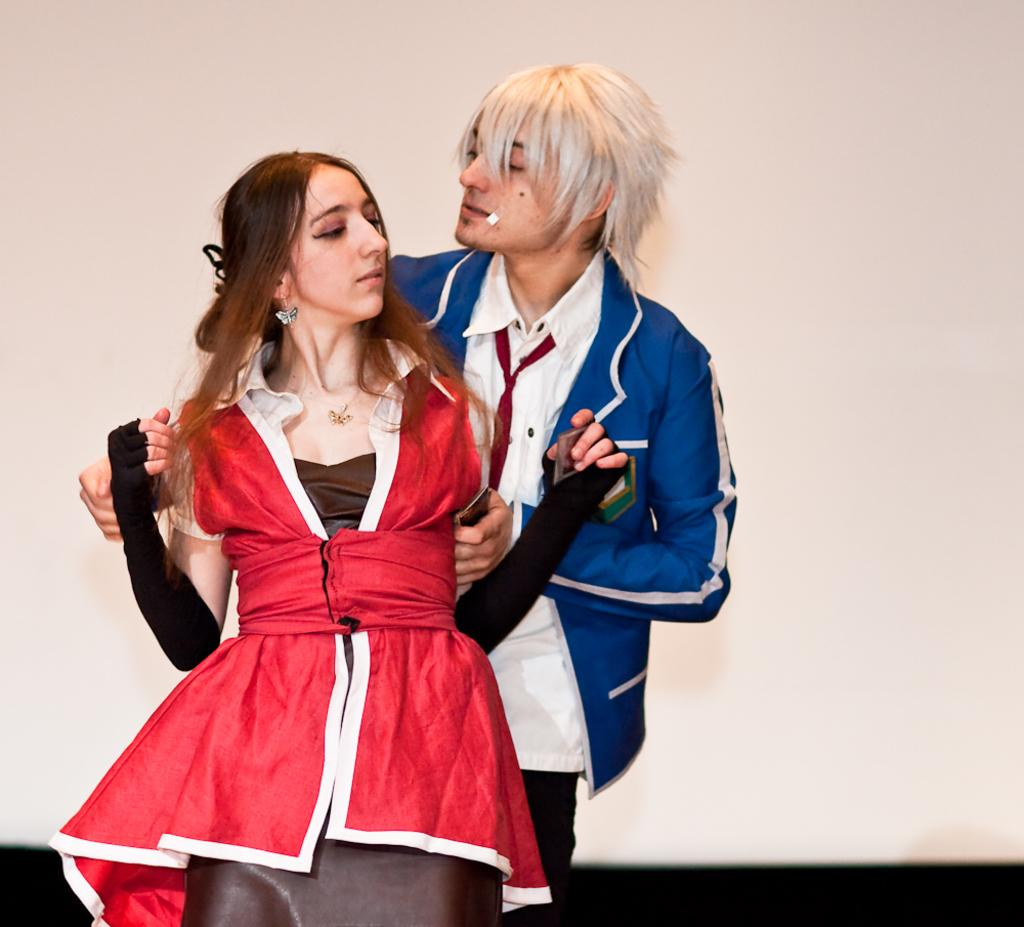How many people are in the image? There are two people in the image. What colors are the dresses worn by the people in the image? One person is wearing a red dress, one person is wearing a brown dress, one person is wearing a white dress, and one person is wearing a blue dress. What is the color of the background in the image? The background of the image is white. What type of detail can be seen on the dresses in the image? The provided facts do not mention any specific details on the dresses, so we cannot answer this question definitively. --- Facts: 1. There is a car in the image. 2. The car is red. 3. The car has four wheels. 4. The car has a license plate. 5. The license plate has numbers and letters. Absurd Topics: parrot, ocean, dance Conversation: What is the main subject of the image? The main subject of the image is a car. What color is the car in the image? The car is red. How many wheels does the car have? The car has four wheels. Does the car have any identifying features in the image? Yes, the car has a license plate. What is written on the license plate? The license plate has numbers and letters. Reasoning: Let's think step by step in order to produce the conversation. We start by identifying the main subject of the image, which is the car. Then, we describe the color and number of wheels of the car. Next, we mention the presence of a license plate and describe its contents. Each question is designed to elicit a specific detail about the image that is known from the provided facts. Absurd Question/Answer: Can you see a parrot flying over the car in the image? There is no parrot present in the image. Is the car parked near the ocean in the image? The provided facts do not mention any ocean or water body in the image. 